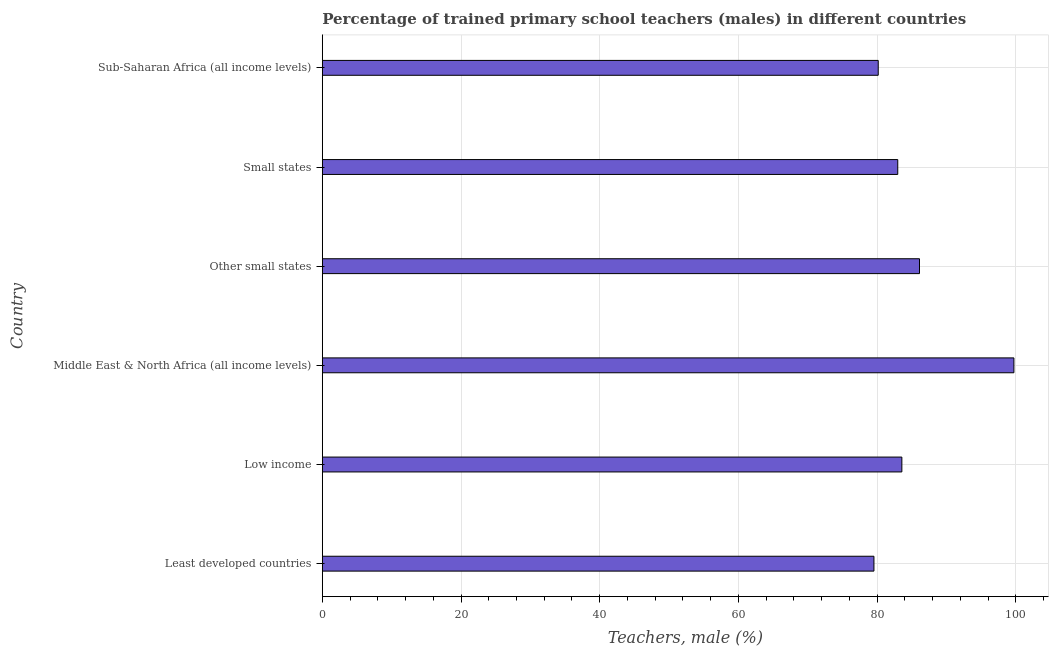Does the graph contain grids?
Provide a succinct answer. Yes. What is the title of the graph?
Give a very brief answer. Percentage of trained primary school teachers (males) in different countries. What is the label or title of the X-axis?
Your answer should be very brief. Teachers, male (%). What is the label or title of the Y-axis?
Provide a short and direct response. Country. What is the percentage of trained male teachers in Other small states?
Offer a terse response. 86.11. Across all countries, what is the maximum percentage of trained male teachers?
Give a very brief answer. 99.73. Across all countries, what is the minimum percentage of trained male teachers?
Provide a short and direct response. 79.54. In which country was the percentage of trained male teachers maximum?
Make the answer very short. Middle East & North Africa (all income levels). In which country was the percentage of trained male teachers minimum?
Your response must be concise. Least developed countries. What is the sum of the percentage of trained male teachers?
Make the answer very short. 512.1. What is the difference between the percentage of trained male teachers in Low income and Other small states?
Your answer should be very brief. -2.54. What is the average percentage of trained male teachers per country?
Give a very brief answer. 85.35. What is the median percentage of trained male teachers?
Make the answer very short. 83.27. What is the ratio of the percentage of trained male teachers in Low income to that in Sub-Saharan Africa (all income levels)?
Offer a terse response. 1.04. What is the difference between the highest and the second highest percentage of trained male teachers?
Keep it short and to the point. 13.62. What is the difference between the highest and the lowest percentage of trained male teachers?
Ensure brevity in your answer.  20.18. In how many countries, is the percentage of trained male teachers greater than the average percentage of trained male teachers taken over all countries?
Your answer should be very brief. 2. How many countries are there in the graph?
Your answer should be compact. 6. Are the values on the major ticks of X-axis written in scientific E-notation?
Provide a short and direct response. No. What is the Teachers, male (%) in Least developed countries?
Provide a short and direct response. 79.54. What is the Teachers, male (%) in Low income?
Your answer should be very brief. 83.57. What is the Teachers, male (%) of Middle East & North Africa (all income levels)?
Provide a short and direct response. 99.73. What is the Teachers, male (%) of Other small states?
Make the answer very short. 86.11. What is the Teachers, male (%) in Small states?
Provide a succinct answer. 82.98. What is the Teachers, male (%) of Sub-Saharan Africa (all income levels)?
Keep it short and to the point. 80.16. What is the difference between the Teachers, male (%) in Least developed countries and Low income?
Provide a succinct answer. -4.03. What is the difference between the Teachers, male (%) in Least developed countries and Middle East & North Africa (all income levels)?
Give a very brief answer. -20.18. What is the difference between the Teachers, male (%) in Least developed countries and Other small states?
Make the answer very short. -6.57. What is the difference between the Teachers, male (%) in Least developed countries and Small states?
Keep it short and to the point. -3.43. What is the difference between the Teachers, male (%) in Least developed countries and Sub-Saharan Africa (all income levels)?
Give a very brief answer. -0.62. What is the difference between the Teachers, male (%) in Low income and Middle East & North Africa (all income levels)?
Give a very brief answer. -16.16. What is the difference between the Teachers, male (%) in Low income and Other small states?
Give a very brief answer. -2.54. What is the difference between the Teachers, male (%) in Low income and Small states?
Make the answer very short. 0.59. What is the difference between the Teachers, male (%) in Low income and Sub-Saharan Africa (all income levels)?
Provide a succinct answer. 3.41. What is the difference between the Teachers, male (%) in Middle East & North Africa (all income levels) and Other small states?
Keep it short and to the point. 13.61. What is the difference between the Teachers, male (%) in Middle East & North Africa (all income levels) and Small states?
Offer a very short reply. 16.75. What is the difference between the Teachers, male (%) in Middle East & North Africa (all income levels) and Sub-Saharan Africa (all income levels)?
Keep it short and to the point. 19.56. What is the difference between the Teachers, male (%) in Other small states and Small states?
Keep it short and to the point. 3.14. What is the difference between the Teachers, male (%) in Other small states and Sub-Saharan Africa (all income levels)?
Your answer should be very brief. 5.95. What is the difference between the Teachers, male (%) in Small states and Sub-Saharan Africa (all income levels)?
Offer a terse response. 2.81. What is the ratio of the Teachers, male (%) in Least developed countries to that in Low income?
Your response must be concise. 0.95. What is the ratio of the Teachers, male (%) in Least developed countries to that in Middle East & North Africa (all income levels)?
Your response must be concise. 0.8. What is the ratio of the Teachers, male (%) in Least developed countries to that in Other small states?
Offer a terse response. 0.92. What is the ratio of the Teachers, male (%) in Low income to that in Middle East & North Africa (all income levels)?
Keep it short and to the point. 0.84. What is the ratio of the Teachers, male (%) in Low income to that in Other small states?
Ensure brevity in your answer.  0.97. What is the ratio of the Teachers, male (%) in Low income to that in Small states?
Keep it short and to the point. 1.01. What is the ratio of the Teachers, male (%) in Low income to that in Sub-Saharan Africa (all income levels)?
Your answer should be compact. 1.04. What is the ratio of the Teachers, male (%) in Middle East & North Africa (all income levels) to that in Other small states?
Make the answer very short. 1.16. What is the ratio of the Teachers, male (%) in Middle East & North Africa (all income levels) to that in Small states?
Your response must be concise. 1.2. What is the ratio of the Teachers, male (%) in Middle East & North Africa (all income levels) to that in Sub-Saharan Africa (all income levels)?
Provide a short and direct response. 1.24. What is the ratio of the Teachers, male (%) in Other small states to that in Small states?
Keep it short and to the point. 1.04. What is the ratio of the Teachers, male (%) in Other small states to that in Sub-Saharan Africa (all income levels)?
Your answer should be very brief. 1.07. What is the ratio of the Teachers, male (%) in Small states to that in Sub-Saharan Africa (all income levels)?
Your answer should be compact. 1.03. 